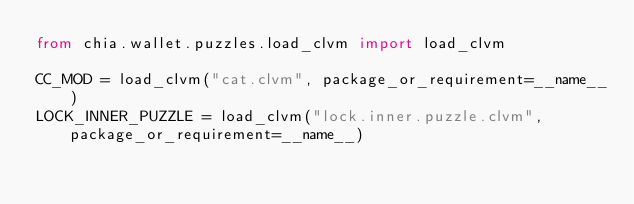<code> <loc_0><loc_0><loc_500><loc_500><_Python_>from chia.wallet.puzzles.load_clvm import load_clvm

CC_MOD = load_clvm("cat.clvm", package_or_requirement=__name__)
LOCK_INNER_PUZZLE = load_clvm("lock.inner.puzzle.clvm", package_or_requirement=__name__)
</code> 